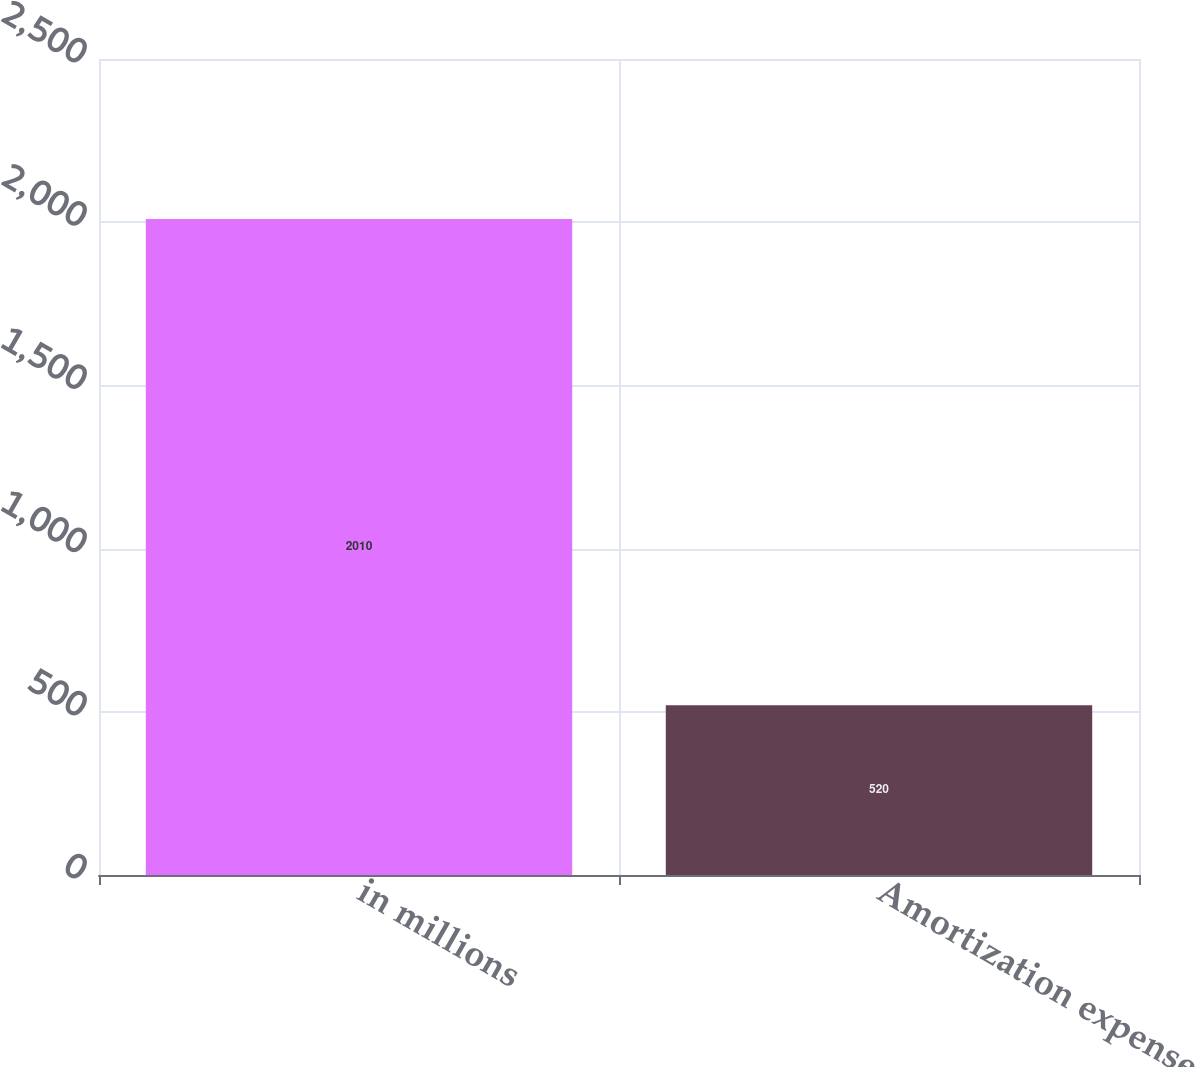<chart> <loc_0><loc_0><loc_500><loc_500><bar_chart><fcel>in millions<fcel>Amortization expense<nl><fcel>2010<fcel>520<nl></chart> 